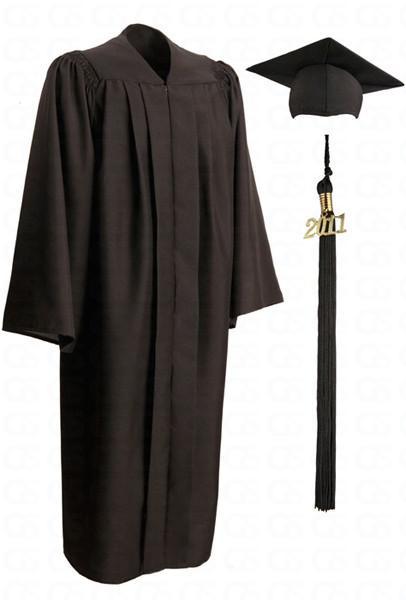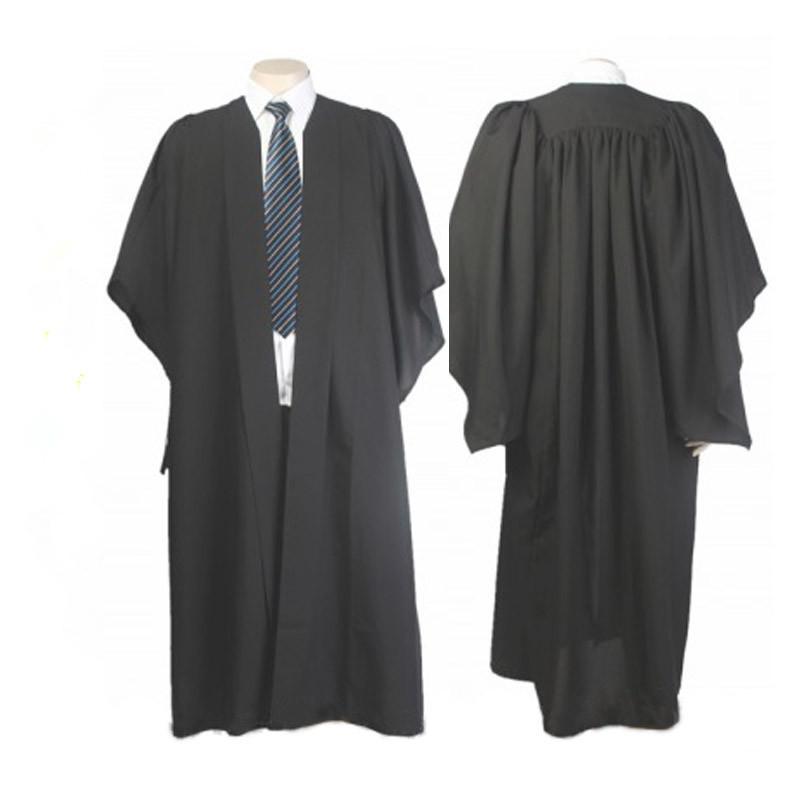The first image is the image on the left, the second image is the image on the right. Assess this claim about the two images: "An image includes a young man standing at a leftward-turned angle, modeling a graduation robe and cap.". Correct or not? Answer yes or no. No. The first image is the image on the left, the second image is the image on the right. Considering the images on both sides, is "There are more unworn clothes than people." valid? Answer yes or no. Yes. 